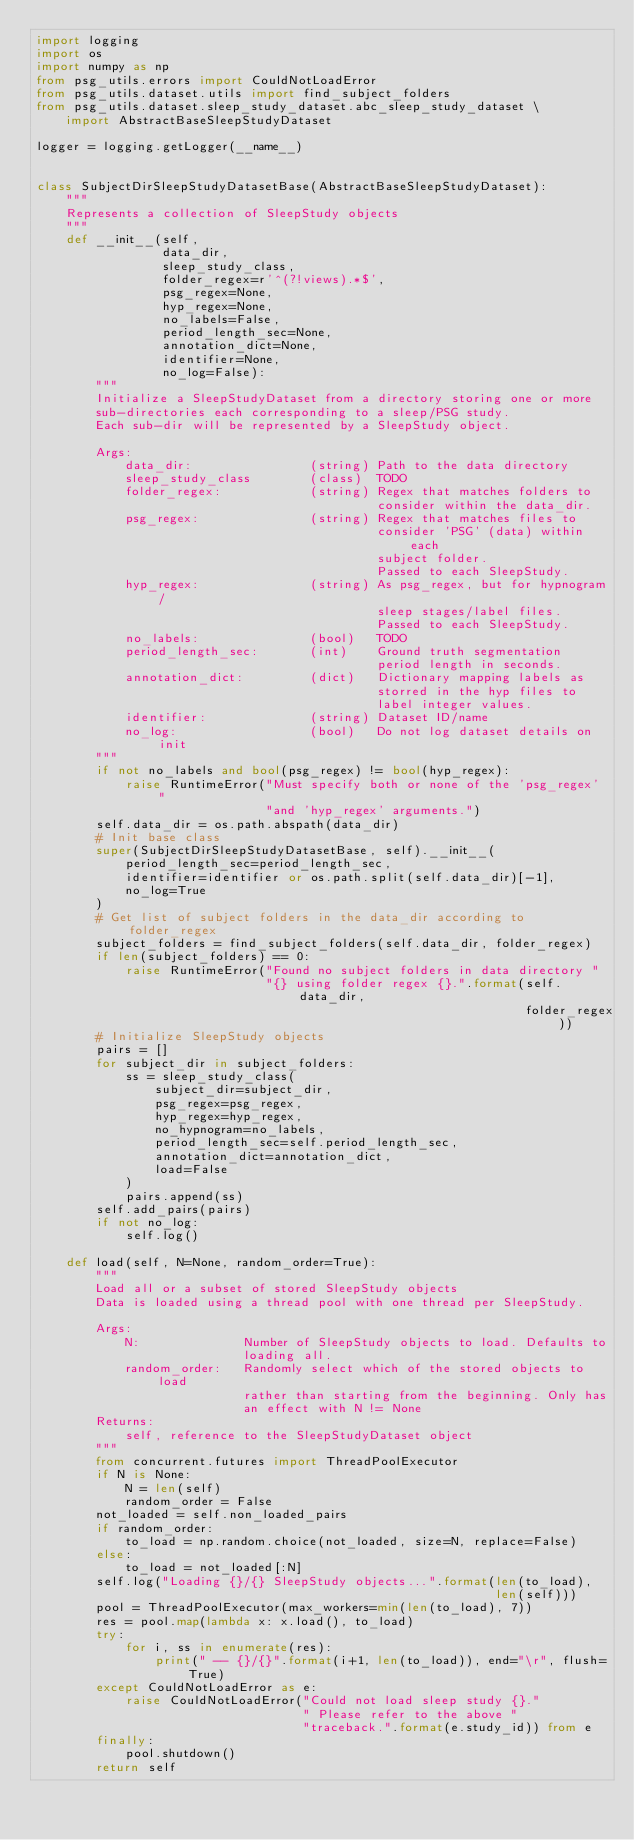<code> <loc_0><loc_0><loc_500><loc_500><_Python_>import logging
import os
import numpy as np
from psg_utils.errors import CouldNotLoadError
from psg_utils.dataset.utils import find_subject_folders
from psg_utils.dataset.sleep_study_dataset.abc_sleep_study_dataset \
    import AbstractBaseSleepStudyDataset

logger = logging.getLogger(__name__)


class SubjectDirSleepStudyDatasetBase(AbstractBaseSleepStudyDataset):
    """
    Represents a collection of SleepStudy objects
    """
    def __init__(self,
                 data_dir,
                 sleep_study_class,
                 folder_regex=r'^(?!views).*$',
                 psg_regex=None,
                 hyp_regex=None,
                 no_labels=False,
                 period_length_sec=None,
                 annotation_dict=None,
                 identifier=None,
                 no_log=False):
        """
        Initialize a SleepStudyDataset from a directory storing one or more
        sub-directories each corresponding to a sleep/PSG study.
        Each sub-dir will be represented by a SleepStudy object.

        Args:
            data_dir:                (string) Path to the data directory
            sleep_study_class        (class)  TODO
            folder_regex:            (string) Regex that matches folders to
                                              consider within the data_dir.
            psg_regex:               (string) Regex that matches files to
                                              consider 'PSG' (data) within each
                                              subject folder.
                                              Passed to each SleepStudy.
            hyp_regex:               (string) As psg_regex, but for hypnogram/
                                              sleep stages/label files.
                                              Passed to each SleepStudy.
            no_labels:               (bool)   TODO
            period_length_sec:       (int)    Ground truth segmentation
                                              period length in seconds.
            annotation_dict:         (dict)   Dictionary mapping labels as
                                              storred in the hyp files to
                                              label integer values.
            identifier:              (string) Dataset ID/name
            no_log:                  (bool)   Do not log dataset details on init
        """
        if not no_labels and bool(psg_regex) != bool(hyp_regex):
            raise RuntimeError("Must specify both or none of the 'psg_regex' "
                               "and 'hyp_regex' arguments.")
        self.data_dir = os.path.abspath(data_dir)
        # Init base class
        super(SubjectDirSleepStudyDatasetBase, self).__init__(
            period_length_sec=period_length_sec,
            identifier=identifier or os.path.split(self.data_dir)[-1],
            no_log=True
        )
        # Get list of subject folders in the data_dir according to folder_regex
        subject_folders = find_subject_folders(self.data_dir, folder_regex)
        if len(subject_folders) == 0:
            raise RuntimeError("Found no subject folders in data directory "
                               "{} using folder regex {}.".format(self.data_dir,
                                                                  folder_regex))
        # Initialize SleepStudy objects
        pairs = []
        for subject_dir in subject_folders:
            ss = sleep_study_class(
                subject_dir=subject_dir,
                psg_regex=psg_regex,
                hyp_regex=hyp_regex,
                no_hypnogram=no_labels,
                period_length_sec=self.period_length_sec,
                annotation_dict=annotation_dict,
                load=False
            )
            pairs.append(ss)
        self.add_pairs(pairs)
        if not no_log:
            self.log()

    def load(self, N=None, random_order=True):
        """
        Load all or a subset of stored SleepStudy objects
        Data is loaded using a thread pool with one thread per SleepStudy.

        Args:
            N:              Number of SleepStudy objects to load. Defaults to
                            loading all.
            random_order:   Randomly select which of the stored objects to load
                            rather than starting from the beginning. Only has
                            an effect with N != None
        Returns:
            self, reference to the SleepStudyDataset object
        """
        from concurrent.futures import ThreadPoolExecutor
        if N is None:
            N = len(self)
            random_order = False
        not_loaded = self.non_loaded_pairs
        if random_order:
            to_load = np.random.choice(not_loaded, size=N, replace=False)
        else:
            to_load = not_loaded[:N]
        self.log("Loading {}/{} SleepStudy objects...".format(len(to_load),
                                                              len(self)))
        pool = ThreadPoolExecutor(max_workers=min(len(to_load), 7))
        res = pool.map(lambda x: x.load(), to_load)
        try:
            for i, ss in enumerate(res):
                print(" -- {}/{}".format(i+1, len(to_load)), end="\r", flush=True)
        except CouldNotLoadError as e:
            raise CouldNotLoadError("Could not load sleep study {}."
                                    " Please refer to the above "
                                    "traceback.".format(e.study_id)) from e
        finally:
            pool.shutdown()
        return self
</code> 